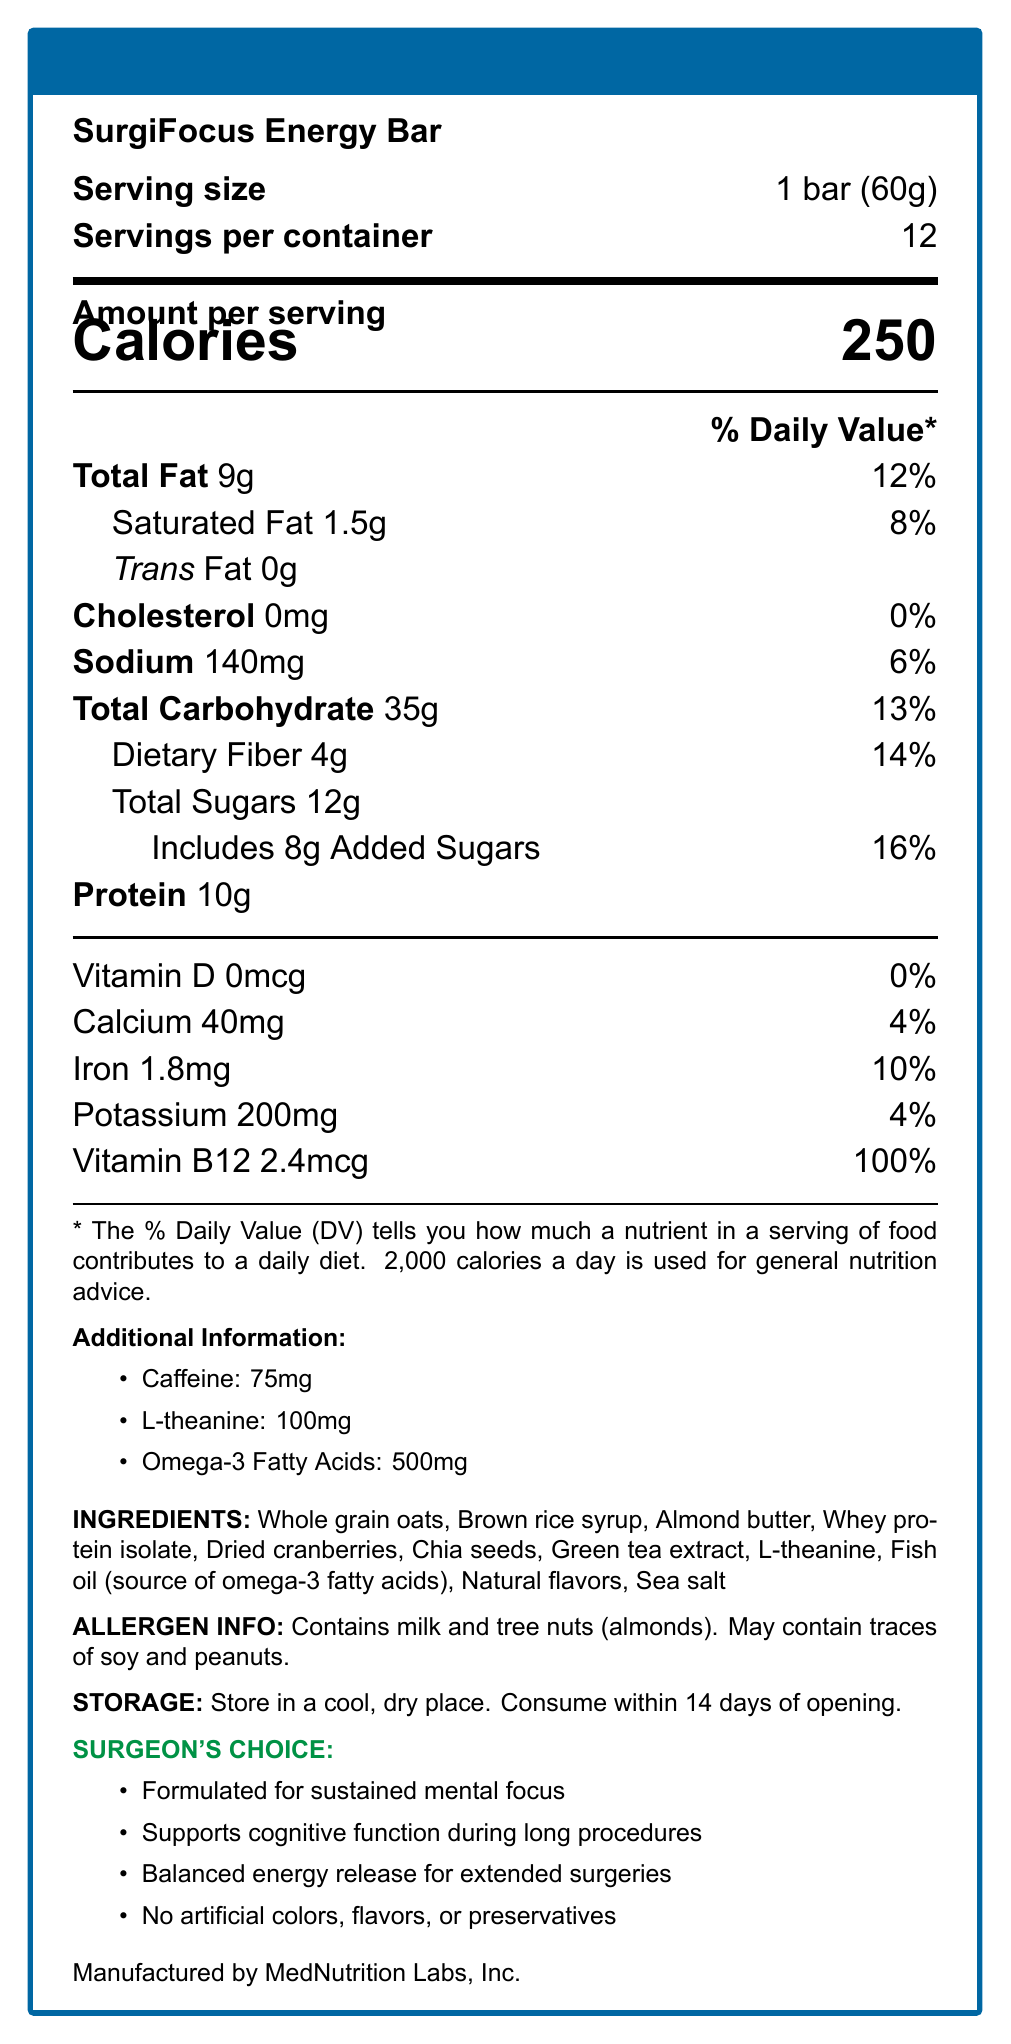what is the serving size for the SurgiFocus Energy Bar? The serving size is directly listed as "1 bar (60g)" under the "Serving size" section.
Answer: 1 bar (60g) how many calories are in one serving of the SurgiFocus Energy Bar? The calories per serving are clearly indicated as "250" in the "Amount per serving" section.
Answer: 250 what is the daily value percentage of dietary fiber in one SurgiFocus Energy Bar? The percentage of the daily value for dietary fiber is listed as "14%" in the nutritional information.
Answer: 14% which vitamin has 100% daily value in one serving of the SurgiFocus Energy Bar? The daily value percentage for vitamin B12 is listed as "100%" in the nutritional information.
Answer: Vitamin B12 how should the SurgiFocus Energy Bar be stored? The storage instructions detail that the bar should be stored in a cool, dry place and consumed within 14 days of opening.
Answer: Store in a cool, dry place. Consume within 14 days of opening. which of the following ingredients is a source of omega-3 fatty acids? A. Chia Seeds B. Fish Oil C. Green Tea Extract D. Almond Butter Fish oil is mentioned as the source of omega-3 fatty acids in the ingredients list.
Answer: B. Fish Oil how much protein is in one serving of the SurgiFocus Energy Bar? A. 4g B. 9g C. 10g D. 12g The amount of protein is indicated as "10g" per serving in the nutritional information.
Answer: C. 10g does the SurgiFocus Energy Bar contain any trans fat? The trans fat content is listed as "0g," indicating that there is no trans fat in the product.
Answer: No summarize the main purpose and unique features of the SurgiFocus Energy Bar. The main purpose of the SurgiFocus Energy Bar is to provide sustained mental focus and support cognitive function during long surgical procedures. It includes claims like "Formulated for sustained mental focus," "Supports cognitive function during long procedures," and "Balanced energy release for extended surgeries."
Answer: Formulated for sustained mental focus, supports cognitive function during long procedures, contains balanced energy release. is there any artificial coloring in the SurgiFocus Energy Bar? The claims section states that there are "No artificial colors, flavors, or preservatives."
Answer: No how many servings are there per container of the SurgiFocus Energy Bar? The container has 12 servings, as indicated in the nutritional information section.
Answer: 12 how much caffeine is in one serving of the SurgiFocus Energy Bar? The amount of caffeine is specified as "75mg" in the additional information section.
Answer: 75mg what are the total carbohydrates and their daily value percentage in one serving of the SurgiFocus Energy Bar? The total carbohydrates amount to "35g" and their daily value percentage is "13%," as per the nutritional information.
Answer: 35g, 13% which of the following allergens are present in the SurgiFocus Energy Bar? I. Milk II. Tree Nuts III. Soy IV. Peanuts Contains milk and tree nuts (almonds) as mentioned in the allergen information.
Answer: I. Milk, II. Tree Nuts is there any information about the manufacturing location stated in the document? There is no specific mention of the manufacturing location in the document. The manufacturer is listed as MedNutrition Labs, Inc., but the location is not provided.
Answer: No 